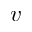Convert formula to latex. <formula><loc_0><loc_0><loc_500><loc_500>v</formula> 